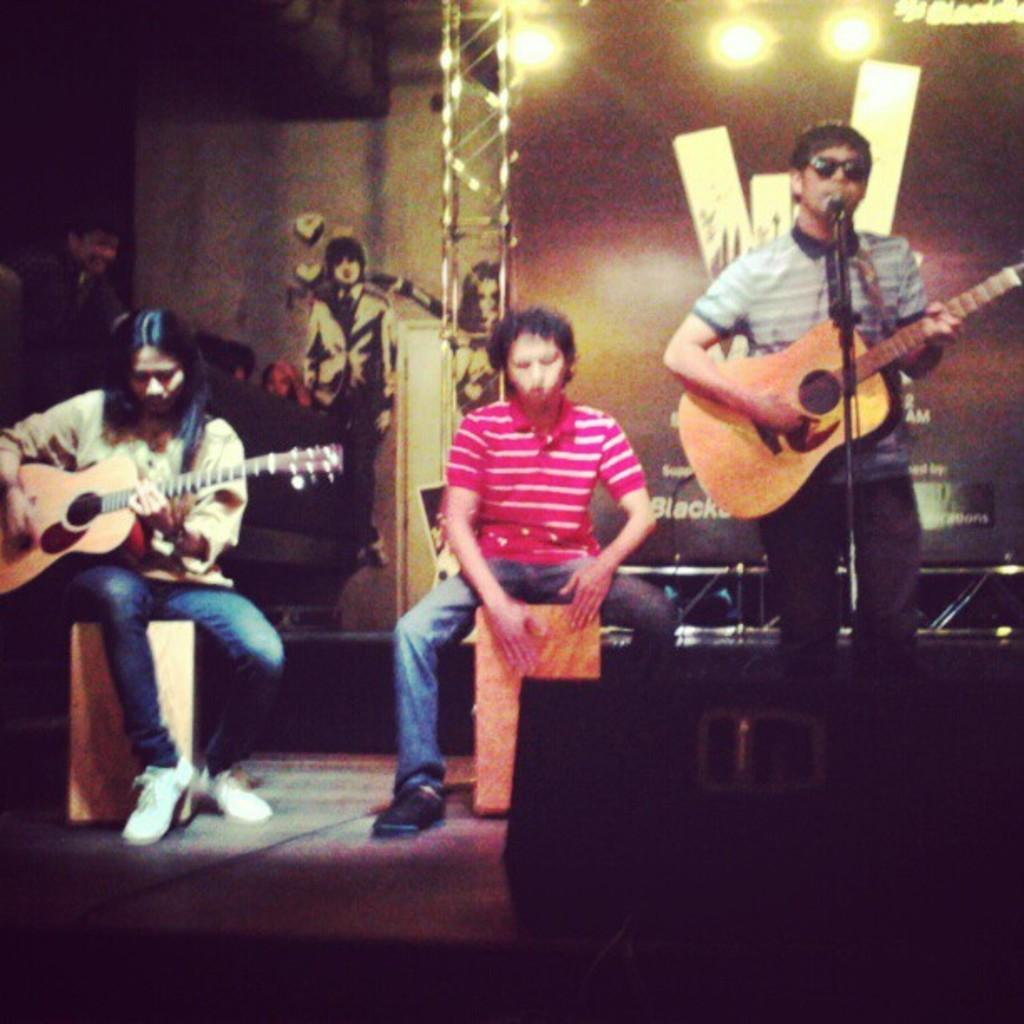How many people are in the image? There are three people in the image. What is the gender of the people in the image? All three people are men. What are two of the men doing in the image? Two of the men are playing guitars. What can be seen in the background of the image? There is a wall and lights visible in the background. What type of flock can be seen flying in the image? There is no flock visible in the image; it features three men, two of whom are playing guitars, with a wall and lights in the background. 